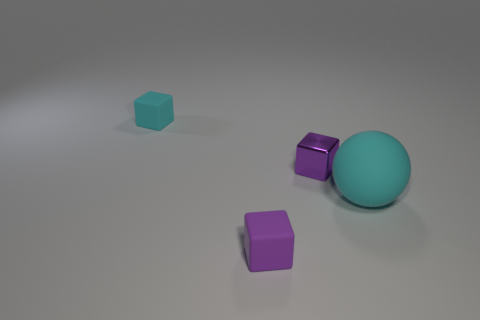Is there anything else that has the same size as the rubber ball?
Your answer should be compact. No. Do the large cyan rubber object and the small cyan thing have the same shape?
Give a very brief answer. No. There is another tiny block that is the same color as the metallic block; what is it made of?
Provide a succinct answer. Rubber. Is the color of the metal thing the same as the big matte object?
Your answer should be compact. No. How many tiny purple rubber blocks are in front of the rubber cube on the left side of the small rubber cube in front of the cyan ball?
Offer a terse response. 1. What shape is the big thing that is made of the same material as the cyan block?
Your answer should be compact. Sphere. What material is the tiny cube in front of the cyan object in front of the cube behind the metal thing?
Ensure brevity in your answer.  Rubber. What number of things are rubber blocks right of the small cyan object or tiny shiny blocks?
Ensure brevity in your answer.  2. How many other objects are there of the same shape as the small purple rubber thing?
Ensure brevity in your answer.  2. Is the number of large matte balls right of the large object greater than the number of tiny purple rubber objects?
Make the answer very short. No. 